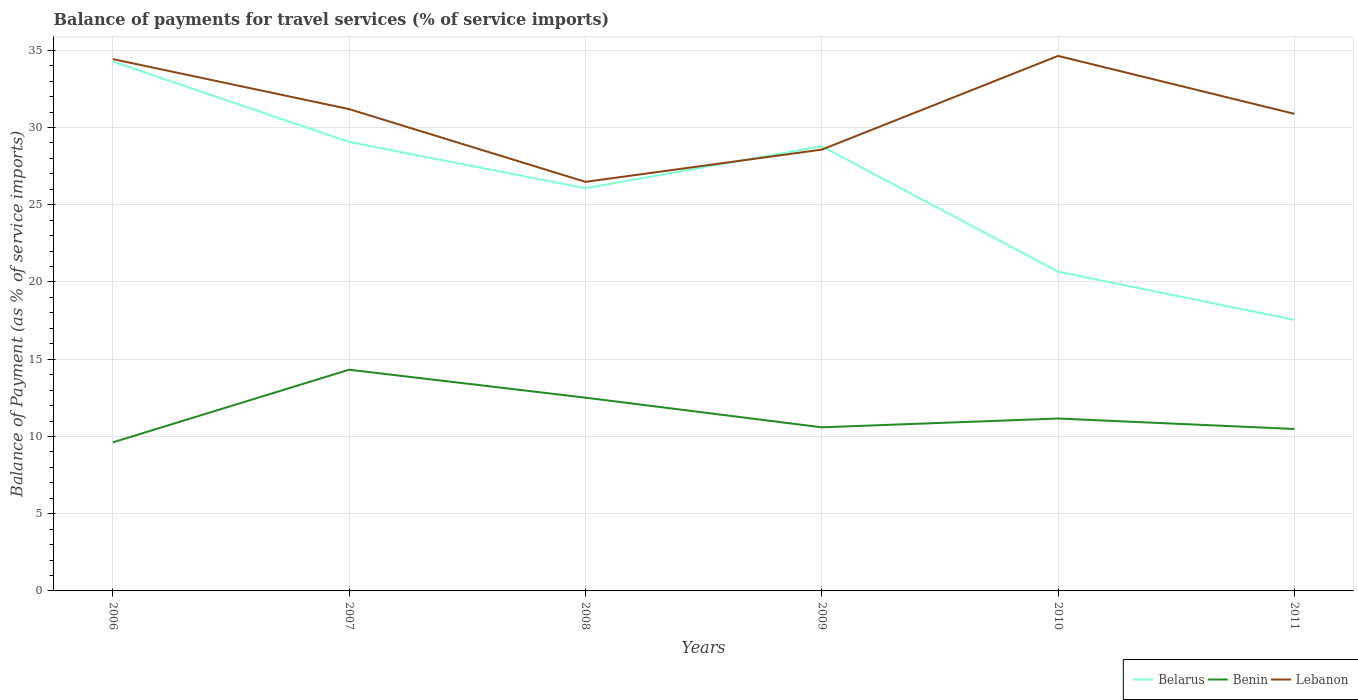Across all years, what is the maximum balance of payments for travel services in Lebanon?
Offer a terse response. 26.48. In which year was the balance of payments for travel services in Benin maximum?
Offer a terse response. 2006. What is the total balance of payments for travel services in Benin in the graph?
Provide a short and direct response. 1.35. What is the difference between the highest and the second highest balance of payments for travel services in Benin?
Offer a terse response. 4.7. What is the difference between the highest and the lowest balance of payments for travel services in Lebanon?
Your answer should be compact. 3. Is the balance of payments for travel services in Belarus strictly greater than the balance of payments for travel services in Lebanon over the years?
Give a very brief answer. No. How many years are there in the graph?
Ensure brevity in your answer.  6. Does the graph contain grids?
Your response must be concise. Yes. Where does the legend appear in the graph?
Your answer should be very brief. Bottom right. How many legend labels are there?
Give a very brief answer. 3. What is the title of the graph?
Your answer should be very brief. Balance of payments for travel services (% of service imports). Does "Costa Rica" appear as one of the legend labels in the graph?
Provide a short and direct response. No. What is the label or title of the Y-axis?
Ensure brevity in your answer.  Balance of Payment (as % of service imports). What is the Balance of Payment (as % of service imports) in Belarus in 2006?
Your response must be concise. 34.27. What is the Balance of Payment (as % of service imports) in Benin in 2006?
Your response must be concise. 9.62. What is the Balance of Payment (as % of service imports) of Lebanon in 2006?
Offer a very short reply. 34.43. What is the Balance of Payment (as % of service imports) in Belarus in 2007?
Ensure brevity in your answer.  29.07. What is the Balance of Payment (as % of service imports) in Benin in 2007?
Ensure brevity in your answer.  14.32. What is the Balance of Payment (as % of service imports) in Lebanon in 2007?
Your response must be concise. 31.19. What is the Balance of Payment (as % of service imports) of Belarus in 2008?
Offer a very short reply. 26.07. What is the Balance of Payment (as % of service imports) in Benin in 2008?
Make the answer very short. 12.51. What is the Balance of Payment (as % of service imports) in Lebanon in 2008?
Provide a succinct answer. 26.48. What is the Balance of Payment (as % of service imports) in Belarus in 2009?
Provide a short and direct response. 28.79. What is the Balance of Payment (as % of service imports) of Benin in 2009?
Provide a succinct answer. 10.59. What is the Balance of Payment (as % of service imports) in Lebanon in 2009?
Your response must be concise. 28.57. What is the Balance of Payment (as % of service imports) of Belarus in 2010?
Provide a succinct answer. 20.67. What is the Balance of Payment (as % of service imports) in Benin in 2010?
Your answer should be compact. 11.16. What is the Balance of Payment (as % of service imports) in Lebanon in 2010?
Ensure brevity in your answer.  34.64. What is the Balance of Payment (as % of service imports) of Belarus in 2011?
Provide a succinct answer. 17.55. What is the Balance of Payment (as % of service imports) of Benin in 2011?
Offer a very short reply. 10.48. What is the Balance of Payment (as % of service imports) of Lebanon in 2011?
Your answer should be compact. 30.89. Across all years, what is the maximum Balance of Payment (as % of service imports) in Belarus?
Ensure brevity in your answer.  34.27. Across all years, what is the maximum Balance of Payment (as % of service imports) in Benin?
Your answer should be compact. 14.32. Across all years, what is the maximum Balance of Payment (as % of service imports) of Lebanon?
Offer a terse response. 34.64. Across all years, what is the minimum Balance of Payment (as % of service imports) in Belarus?
Provide a succinct answer. 17.55. Across all years, what is the minimum Balance of Payment (as % of service imports) of Benin?
Your answer should be very brief. 9.62. Across all years, what is the minimum Balance of Payment (as % of service imports) of Lebanon?
Offer a very short reply. 26.48. What is the total Balance of Payment (as % of service imports) of Belarus in the graph?
Offer a terse response. 156.41. What is the total Balance of Payment (as % of service imports) of Benin in the graph?
Your response must be concise. 68.68. What is the total Balance of Payment (as % of service imports) of Lebanon in the graph?
Your response must be concise. 186.2. What is the difference between the Balance of Payment (as % of service imports) in Belarus in 2006 and that in 2007?
Keep it short and to the point. 5.2. What is the difference between the Balance of Payment (as % of service imports) in Benin in 2006 and that in 2007?
Give a very brief answer. -4.7. What is the difference between the Balance of Payment (as % of service imports) of Lebanon in 2006 and that in 2007?
Your answer should be very brief. 3.24. What is the difference between the Balance of Payment (as % of service imports) in Belarus in 2006 and that in 2008?
Provide a short and direct response. 8.2. What is the difference between the Balance of Payment (as % of service imports) of Benin in 2006 and that in 2008?
Your answer should be compact. -2.89. What is the difference between the Balance of Payment (as % of service imports) in Lebanon in 2006 and that in 2008?
Your answer should be very brief. 7.95. What is the difference between the Balance of Payment (as % of service imports) in Belarus in 2006 and that in 2009?
Keep it short and to the point. 5.48. What is the difference between the Balance of Payment (as % of service imports) of Benin in 2006 and that in 2009?
Offer a terse response. -0.97. What is the difference between the Balance of Payment (as % of service imports) in Lebanon in 2006 and that in 2009?
Your answer should be compact. 5.86. What is the difference between the Balance of Payment (as % of service imports) of Belarus in 2006 and that in 2010?
Your response must be concise. 13.6. What is the difference between the Balance of Payment (as % of service imports) of Benin in 2006 and that in 2010?
Your answer should be compact. -1.54. What is the difference between the Balance of Payment (as % of service imports) in Lebanon in 2006 and that in 2010?
Offer a terse response. -0.21. What is the difference between the Balance of Payment (as % of service imports) of Belarus in 2006 and that in 2011?
Your answer should be compact. 16.72. What is the difference between the Balance of Payment (as % of service imports) in Benin in 2006 and that in 2011?
Your answer should be compact. -0.87. What is the difference between the Balance of Payment (as % of service imports) of Lebanon in 2006 and that in 2011?
Your response must be concise. 3.54. What is the difference between the Balance of Payment (as % of service imports) in Belarus in 2007 and that in 2008?
Provide a short and direct response. 3. What is the difference between the Balance of Payment (as % of service imports) in Benin in 2007 and that in 2008?
Ensure brevity in your answer.  1.81. What is the difference between the Balance of Payment (as % of service imports) in Lebanon in 2007 and that in 2008?
Provide a succinct answer. 4.71. What is the difference between the Balance of Payment (as % of service imports) of Belarus in 2007 and that in 2009?
Keep it short and to the point. 0.28. What is the difference between the Balance of Payment (as % of service imports) in Benin in 2007 and that in 2009?
Your response must be concise. 3.73. What is the difference between the Balance of Payment (as % of service imports) in Lebanon in 2007 and that in 2009?
Your answer should be very brief. 2.62. What is the difference between the Balance of Payment (as % of service imports) of Belarus in 2007 and that in 2010?
Your answer should be compact. 8.4. What is the difference between the Balance of Payment (as % of service imports) in Benin in 2007 and that in 2010?
Your answer should be compact. 3.16. What is the difference between the Balance of Payment (as % of service imports) of Lebanon in 2007 and that in 2010?
Make the answer very short. -3.44. What is the difference between the Balance of Payment (as % of service imports) of Belarus in 2007 and that in 2011?
Make the answer very short. 11.52. What is the difference between the Balance of Payment (as % of service imports) of Benin in 2007 and that in 2011?
Provide a succinct answer. 3.84. What is the difference between the Balance of Payment (as % of service imports) of Lebanon in 2007 and that in 2011?
Offer a terse response. 0.31. What is the difference between the Balance of Payment (as % of service imports) in Belarus in 2008 and that in 2009?
Provide a succinct answer. -2.72. What is the difference between the Balance of Payment (as % of service imports) in Benin in 2008 and that in 2009?
Provide a short and direct response. 1.92. What is the difference between the Balance of Payment (as % of service imports) of Lebanon in 2008 and that in 2009?
Ensure brevity in your answer.  -2.09. What is the difference between the Balance of Payment (as % of service imports) in Belarus in 2008 and that in 2010?
Offer a terse response. 5.4. What is the difference between the Balance of Payment (as % of service imports) in Benin in 2008 and that in 2010?
Give a very brief answer. 1.35. What is the difference between the Balance of Payment (as % of service imports) in Lebanon in 2008 and that in 2010?
Keep it short and to the point. -8.15. What is the difference between the Balance of Payment (as % of service imports) of Belarus in 2008 and that in 2011?
Provide a short and direct response. 8.52. What is the difference between the Balance of Payment (as % of service imports) in Benin in 2008 and that in 2011?
Your response must be concise. 2.03. What is the difference between the Balance of Payment (as % of service imports) in Lebanon in 2008 and that in 2011?
Provide a succinct answer. -4.4. What is the difference between the Balance of Payment (as % of service imports) in Belarus in 2009 and that in 2010?
Ensure brevity in your answer.  8.12. What is the difference between the Balance of Payment (as % of service imports) of Benin in 2009 and that in 2010?
Provide a short and direct response. -0.57. What is the difference between the Balance of Payment (as % of service imports) in Lebanon in 2009 and that in 2010?
Offer a very short reply. -6.07. What is the difference between the Balance of Payment (as % of service imports) of Belarus in 2009 and that in 2011?
Ensure brevity in your answer.  11.24. What is the difference between the Balance of Payment (as % of service imports) of Benin in 2009 and that in 2011?
Offer a very short reply. 0.11. What is the difference between the Balance of Payment (as % of service imports) of Lebanon in 2009 and that in 2011?
Keep it short and to the point. -2.32. What is the difference between the Balance of Payment (as % of service imports) of Belarus in 2010 and that in 2011?
Provide a succinct answer. 3.12. What is the difference between the Balance of Payment (as % of service imports) in Benin in 2010 and that in 2011?
Provide a succinct answer. 0.68. What is the difference between the Balance of Payment (as % of service imports) of Lebanon in 2010 and that in 2011?
Make the answer very short. 3.75. What is the difference between the Balance of Payment (as % of service imports) in Belarus in 2006 and the Balance of Payment (as % of service imports) in Benin in 2007?
Offer a terse response. 19.95. What is the difference between the Balance of Payment (as % of service imports) of Belarus in 2006 and the Balance of Payment (as % of service imports) of Lebanon in 2007?
Your answer should be very brief. 3.08. What is the difference between the Balance of Payment (as % of service imports) in Benin in 2006 and the Balance of Payment (as % of service imports) in Lebanon in 2007?
Your answer should be compact. -21.58. What is the difference between the Balance of Payment (as % of service imports) in Belarus in 2006 and the Balance of Payment (as % of service imports) in Benin in 2008?
Ensure brevity in your answer.  21.76. What is the difference between the Balance of Payment (as % of service imports) in Belarus in 2006 and the Balance of Payment (as % of service imports) in Lebanon in 2008?
Offer a very short reply. 7.79. What is the difference between the Balance of Payment (as % of service imports) in Benin in 2006 and the Balance of Payment (as % of service imports) in Lebanon in 2008?
Ensure brevity in your answer.  -16.87. What is the difference between the Balance of Payment (as % of service imports) of Belarus in 2006 and the Balance of Payment (as % of service imports) of Benin in 2009?
Offer a terse response. 23.68. What is the difference between the Balance of Payment (as % of service imports) in Belarus in 2006 and the Balance of Payment (as % of service imports) in Lebanon in 2009?
Make the answer very short. 5.7. What is the difference between the Balance of Payment (as % of service imports) in Benin in 2006 and the Balance of Payment (as % of service imports) in Lebanon in 2009?
Your response must be concise. -18.95. What is the difference between the Balance of Payment (as % of service imports) of Belarus in 2006 and the Balance of Payment (as % of service imports) of Benin in 2010?
Keep it short and to the point. 23.11. What is the difference between the Balance of Payment (as % of service imports) of Belarus in 2006 and the Balance of Payment (as % of service imports) of Lebanon in 2010?
Your answer should be very brief. -0.37. What is the difference between the Balance of Payment (as % of service imports) of Benin in 2006 and the Balance of Payment (as % of service imports) of Lebanon in 2010?
Your answer should be very brief. -25.02. What is the difference between the Balance of Payment (as % of service imports) of Belarus in 2006 and the Balance of Payment (as % of service imports) of Benin in 2011?
Your answer should be very brief. 23.79. What is the difference between the Balance of Payment (as % of service imports) in Belarus in 2006 and the Balance of Payment (as % of service imports) in Lebanon in 2011?
Provide a succinct answer. 3.38. What is the difference between the Balance of Payment (as % of service imports) in Benin in 2006 and the Balance of Payment (as % of service imports) in Lebanon in 2011?
Ensure brevity in your answer.  -21.27. What is the difference between the Balance of Payment (as % of service imports) in Belarus in 2007 and the Balance of Payment (as % of service imports) in Benin in 2008?
Make the answer very short. 16.56. What is the difference between the Balance of Payment (as % of service imports) of Belarus in 2007 and the Balance of Payment (as % of service imports) of Lebanon in 2008?
Offer a terse response. 2.58. What is the difference between the Balance of Payment (as % of service imports) of Benin in 2007 and the Balance of Payment (as % of service imports) of Lebanon in 2008?
Offer a terse response. -12.16. What is the difference between the Balance of Payment (as % of service imports) of Belarus in 2007 and the Balance of Payment (as % of service imports) of Benin in 2009?
Ensure brevity in your answer.  18.48. What is the difference between the Balance of Payment (as % of service imports) in Belarus in 2007 and the Balance of Payment (as % of service imports) in Lebanon in 2009?
Your answer should be compact. 0.5. What is the difference between the Balance of Payment (as % of service imports) in Benin in 2007 and the Balance of Payment (as % of service imports) in Lebanon in 2009?
Make the answer very short. -14.25. What is the difference between the Balance of Payment (as % of service imports) in Belarus in 2007 and the Balance of Payment (as % of service imports) in Benin in 2010?
Provide a succinct answer. 17.91. What is the difference between the Balance of Payment (as % of service imports) in Belarus in 2007 and the Balance of Payment (as % of service imports) in Lebanon in 2010?
Ensure brevity in your answer.  -5.57. What is the difference between the Balance of Payment (as % of service imports) of Benin in 2007 and the Balance of Payment (as % of service imports) of Lebanon in 2010?
Your response must be concise. -20.32. What is the difference between the Balance of Payment (as % of service imports) of Belarus in 2007 and the Balance of Payment (as % of service imports) of Benin in 2011?
Offer a terse response. 18.58. What is the difference between the Balance of Payment (as % of service imports) of Belarus in 2007 and the Balance of Payment (as % of service imports) of Lebanon in 2011?
Ensure brevity in your answer.  -1.82. What is the difference between the Balance of Payment (as % of service imports) in Benin in 2007 and the Balance of Payment (as % of service imports) in Lebanon in 2011?
Your answer should be compact. -16.56. What is the difference between the Balance of Payment (as % of service imports) of Belarus in 2008 and the Balance of Payment (as % of service imports) of Benin in 2009?
Provide a short and direct response. 15.48. What is the difference between the Balance of Payment (as % of service imports) in Belarus in 2008 and the Balance of Payment (as % of service imports) in Lebanon in 2009?
Provide a succinct answer. -2.5. What is the difference between the Balance of Payment (as % of service imports) in Benin in 2008 and the Balance of Payment (as % of service imports) in Lebanon in 2009?
Your answer should be compact. -16.06. What is the difference between the Balance of Payment (as % of service imports) in Belarus in 2008 and the Balance of Payment (as % of service imports) in Benin in 2010?
Your answer should be very brief. 14.91. What is the difference between the Balance of Payment (as % of service imports) of Belarus in 2008 and the Balance of Payment (as % of service imports) of Lebanon in 2010?
Provide a succinct answer. -8.57. What is the difference between the Balance of Payment (as % of service imports) of Benin in 2008 and the Balance of Payment (as % of service imports) of Lebanon in 2010?
Ensure brevity in your answer.  -22.13. What is the difference between the Balance of Payment (as % of service imports) of Belarus in 2008 and the Balance of Payment (as % of service imports) of Benin in 2011?
Offer a very short reply. 15.59. What is the difference between the Balance of Payment (as % of service imports) in Belarus in 2008 and the Balance of Payment (as % of service imports) in Lebanon in 2011?
Provide a short and direct response. -4.82. What is the difference between the Balance of Payment (as % of service imports) in Benin in 2008 and the Balance of Payment (as % of service imports) in Lebanon in 2011?
Offer a very short reply. -18.37. What is the difference between the Balance of Payment (as % of service imports) in Belarus in 2009 and the Balance of Payment (as % of service imports) in Benin in 2010?
Your response must be concise. 17.63. What is the difference between the Balance of Payment (as % of service imports) of Belarus in 2009 and the Balance of Payment (as % of service imports) of Lebanon in 2010?
Keep it short and to the point. -5.85. What is the difference between the Balance of Payment (as % of service imports) of Benin in 2009 and the Balance of Payment (as % of service imports) of Lebanon in 2010?
Offer a very short reply. -24.05. What is the difference between the Balance of Payment (as % of service imports) in Belarus in 2009 and the Balance of Payment (as % of service imports) in Benin in 2011?
Provide a short and direct response. 18.3. What is the difference between the Balance of Payment (as % of service imports) in Belarus in 2009 and the Balance of Payment (as % of service imports) in Lebanon in 2011?
Keep it short and to the point. -2.1. What is the difference between the Balance of Payment (as % of service imports) of Benin in 2009 and the Balance of Payment (as % of service imports) of Lebanon in 2011?
Provide a succinct answer. -20.29. What is the difference between the Balance of Payment (as % of service imports) in Belarus in 2010 and the Balance of Payment (as % of service imports) in Benin in 2011?
Keep it short and to the point. 10.19. What is the difference between the Balance of Payment (as % of service imports) in Belarus in 2010 and the Balance of Payment (as % of service imports) in Lebanon in 2011?
Offer a terse response. -10.22. What is the difference between the Balance of Payment (as % of service imports) of Benin in 2010 and the Balance of Payment (as % of service imports) of Lebanon in 2011?
Provide a short and direct response. -19.72. What is the average Balance of Payment (as % of service imports) of Belarus per year?
Your answer should be very brief. 26.07. What is the average Balance of Payment (as % of service imports) of Benin per year?
Give a very brief answer. 11.45. What is the average Balance of Payment (as % of service imports) in Lebanon per year?
Offer a very short reply. 31.03. In the year 2006, what is the difference between the Balance of Payment (as % of service imports) in Belarus and Balance of Payment (as % of service imports) in Benin?
Give a very brief answer. 24.65. In the year 2006, what is the difference between the Balance of Payment (as % of service imports) of Belarus and Balance of Payment (as % of service imports) of Lebanon?
Offer a terse response. -0.16. In the year 2006, what is the difference between the Balance of Payment (as % of service imports) in Benin and Balance of Payment (as % of service imports) in Lebanon?
Your answer should be very brief. -24.81. In the year 2007, what is the difference between the Balance of Payment (as % of service imports) of Belarus and Balance of Payment (as % of service imports) of Benin?
Offer a very short reply. 14.75. In the year 2007, what is the difference between the Balance of Payment (as % of service imports) of Belarus and Balance of Payment (as % of service imports) of Lebanon?
Give a very brief answer. -2.12. In the year 2007, what is the difference between the Balance of Payment (as % of service imports) of Benin and Balance of Payment (as % of service imports) of Lebanon?
Offer a very short reply. -16.87. In the year 2008, what is the difference between the Balance of Payment (as % of service imports) in Belarus and Balance of Payment (as % of service imports) in Benin?
Keep it short and to the point. 13.56. In the year 2008, what is the difference between the Balance of Payment (as % of service imports) of Belarus and Balance of Payment (as % of service imports) of Lebanon?
Keep it short and to the point. -0.41. In the year 2008, what is the difference between the Balance of Payment (as % of service imports) of Benin and Balance of Payment (as % of service imports) of Lebanon?
Your response must be concise. -13.97. In the year 2009, what is the difference between the Balance of Payment (as % of service imports) of Belarus and Balance of Payment (as % of service imports) of Benin?
Keep it short and to the point. 18.2. In the year 2009, what is the difference between the Balance of Payment (as % of service imports) of Belarus and Balance of Payment (as % of service imports) of Lebanon?
Ensure brevity in your answer.  0.22. In the year 2009, what is the difference between the Balance of Payment (as % of service imports) in Benin and Balance of Payment (as % of service imports) in Lebanon?
Your answer should be compact. -17.98. In the year 2010, what is the difference between the Balance of Payment (as % of service imports) in Belarus and Balance of Payment (as % of service imports) in Benin?
Offer a very short reply. 9.51. In the year 2010, what is the difference between the Balance of Payment (as % of service imports) of Belarus and Balance of Payment (as % of service imports) of Lebanon?
Your answer should be compact. -13.97. In the year 2010, what is the difference between the Balance of Payment (as % of service imports) in Benin and Balance of Payment (as % of service imports) in Lebanon?
Your answer should be compact. -23.48. In the year 2011, what is the difference between the Balance of Payment (as % of service imports) in Belarus and Balance of Payment (as % of service imports) in Benin?
Your response must be concise. 7.07. In the year 2011, what is the difference between the Balance of Payment (as % of service imports) of Belarus and Balance of Payment (as % of service imports) of Lebanon?
Provide a succinct answer. -13.34. In the year 2011, what is the difference between the Balance of Payment (as % of service imports) of Benin and Balance of Payment (as % of service imports) of Lebanon?
Make the answer very short. -20.4. What is the ratio of the Balance of Payment (as % of service imports) of Belarus in 2006 to that in 2007?
Provide a succinct answer. 1.18. What is the ratio of the Balance of Payment (as % of service imports) of Benin in 2006 to that in 2007?
Your response must be concise. 0.67. What is the ratio of the Balance of Payment (as % of service imports) of Lebanon in 2006 to that in 2007?
Your response must be concise. 1.1. What is the ratio of the Balance of Payment (as % of service imports) in Belarus in 2006 to that in 2008?
Make the answer very short. 1.31. What is the ratio of the Balance of Payment (as % of service imports) of Benin in 2006 to that in 2008?
Offer a very short reply. 0.77. What is the ratio of the Balance of Payment (as % of service imports) of Lebanon in 2006 to that in 2008?
Make the answer very short. 1.3. What is the ratio of the Balance of Payment (as % of service imports) of Belarus in 2006 to that in 2009?
Provide a short and direct response. 1.19. What is the ratio of the Balance of Payment (as % of service imports) in Benin in 2006 to that in 2009?
Your answer should be compact. 0.91. What is the ratio of the Balance of Payment (as % of service imports) in Lebanon in 2006 to that in 2009?
Offer a terse response. 1.21. What is the ratio of the Balance of Payment (as % of service imports) of Belarus in 2006 to that in 2010?
Offer a very short reply. 1.66. What is the ratio of the Balance of Payment (as % of service imports) in Benin in 2006 to that in 2010?
Your answer should be compact. 0.86. What is the ratio of the Balance of Payment (as % of service imports) of Belarus in 2006 to that in 2011?
Make the answer very short. 1.95. What is the ratio of the Balance of Payment (as % of service imports) in Benin in 2006 to that in 2011?
Provide a succinct answer. 0.92. What is the ratio of the Balance of Payment (as % of service imports) in Lebanon in 2006 to that in 2011?
Provide a succinct answer. 1.11. What is the ratio of the Balance of Payment (as % of service imports) of Belarus in 2007 to that in 2008?
Your response must be concise. 1.11. What is the ratio of the Balance of Payment (as % of service imports) of Benin in 2007 to that in 2008?
Ensure brevity in your answer.  1.14. What is the ratio of the Balance of Payment (as % of service imports) of Lebanon in 2007 to that in 2008?
Your response must be concise. 1.18. What is the ratio of the Balance of Payment (as % of service imports) in Belarus in 2007 to that in 2009?
Provide a short and direct response. 1.01. What is the ratio of the Balance of Payment (as % of service imports) of Benin in 2007 to that in 2009?
Offer a very short reply. 1.35. What is the ratio of the Balance of Payment (as % of service imports) of Lebanon in 2007 to that in 2009?
Your answer should be compact. 1.09. What is the ratio of the Balance of Payment (as % of service imports) of Belarus in 2007 to that in 2010?
Your answer should be very brief. 1.41. What is the ratio of the Balance of Payment (as % of service imports) in Benin in 2007 to that in 2010?
Keep it short and to the point. 1.28. What is the ratio of the Balance of Payment (as % of service imports) in Lebanon in 2007 to that in 2010?
Provide a short and direct response. 0.9. What is the ratio of the Balance of Payment (as % of service imports) of Belarus in 2007 to that in 2011?
Offer a very short reply. 1.66. What is the ratio of the Balance of Payment (as % of service imports) in Benin in 2007 to that in 2011?
Provide a short and direct response. 1.37. What is the ratio of the Balance of Payment (as % of service imports) in Lebanon in 2007 to that in 2011?
Provide a short and direct response. 1.01. What is the ratio of the Balance of Payment (as % of service imports) in Belarus in 2008 to that in 2009?
Keep it short and to the point. 0.91. What is the ratio of the Balance of Payment (as % of service imports) of Benin in 2008 to that in 2009?
Your answer should be very brief. 1.18. What is the ratio of the Balance of Payment (as % of service imports) in Lebanon in 2008 to that in 2009?
Keep it short and to the point. 0.93. What is the ratio of the Balance of Payment (as % of service imports) of Belarus in 2008 to that in 2010?
Offer a terse response. 1.26. What is the ratio of the Balance of Payment (as % of service imports) in Benin in 2008 to that in 2010?
Your answer should be compact. 1.12. What is the ratio of the Balance of Payment (as % of service imports) of Lebanon in 2008 to that in 2010?
Offer a very short reply. 0.76. What is the ratio of the Balance of Payment (as % of service imports) in Belarus in 2008 to that in 2011?
Provide a succinct answer. 1.49. What is the ratio of the Balance of Payment (as % of service imports) in Benin in 2008 to that in 2011?
Offer a very short reply. 1.19. What is the ratio of the Balance of Payment (as % of service imports) of Lebanon in 2008 to that in 2011?
Your answer should be very brief. 0.86. What is the ratio of the Balance of Payment (as % of service imports) of Belarus in 2009 to that in 2010?
Your answer should be compact. 1.39. What is the ratio of the Balance of Payment (as % of service imports) in Benin in 2009 to that in 2010?
Give a very brief answer. 0.95. What is the ratio of the Balance of Payment (as % of service imports) in Lebanon in 2009 to that in 2010?
Offer a very short reply. 0.82. What is the ratio of the Balance of Payment (as % of service imports) of Belarus in 2009 to that in 2011?
Give a very brief answer. 1.64. What is the ratio of the Balance of Payment (as % of service imports) of Benin in 2009 to that in 2011?
Your response must be concise. 1.01. What is the ratio of the Balance of Payment (as % of service imports) in Lebanon in 2009 to that in 2011?
Offer a very short reply. 0.93. What is the ratio of the Balance of Payment (as % of service imports) of Belarus in 2010 to that in 2011?
Offer a very short reply. 1.18. What is the ratio of the Balance of Payment (as % of service imports) in Benin in 2010 to that in 2011?
Make the answer very short. 1.06. What is the ratio of the Balance of Payment (as % of service imports) in Lebanon in 2010 to that in 2011?
Provide a succinct answer. 1.12. What is the difference between the highest and the second highest Balance of Payment (as % of service imports) of Belarus?
Ensure brevity in your answer.  5.2. What is the difference between the highest and the second highest Balance of Payment (as % of service imports) in Benin?
Your answer should be very brief. 1.81. What is the difference between the highest and the second highest Balance of Payment (as % of service imports) in Lebanon?
Provide a succinct answer. 0.21. What is the difference between the highest and the lowest Balance of Payment (as % of service imports) in Belarus?
Ensure brevity in your answer.  16.72. What is the difference between the highest and the lowest Balance of Payment (as % of service imports) of Benin?
Offer a terse response. 4.7. What is the difference between the highest and the lowest Balance of Payment (as % of service imports) in Lebanon?
Give a very brief answer. 8.15. 